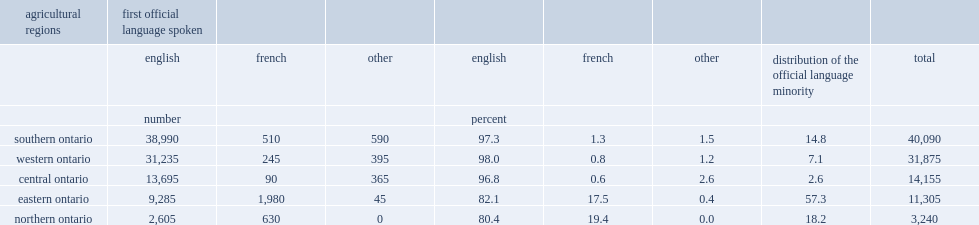In 2011, how many people aged 15 years and older are working in ontario's agricultural sector? 100665. How many percent of workers in ontario belonges to the french-language minority? 0.034322. What percent of workers in ontario are from eastern ontario? 0.112303. In eastern ontario, how many workers belonge to the french-language minority? 1980. What percent of all french-language agricultural workers are in eastern ontario? 0.573082. In 2011, what percent of workers in the ontario's agricultural sector are from northern ontario ? 0.032186. What percent of workers in the northern ontario's agricultural sector were french-language minorities? 0.194444. 